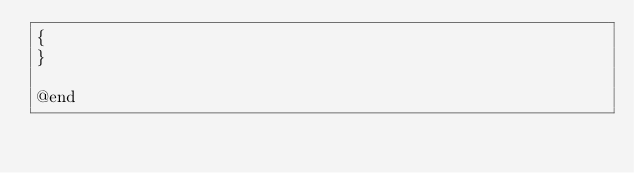<code> <loc_0><loc_0><loc_500><loc_500><_C_>{
}

@end

</code> 